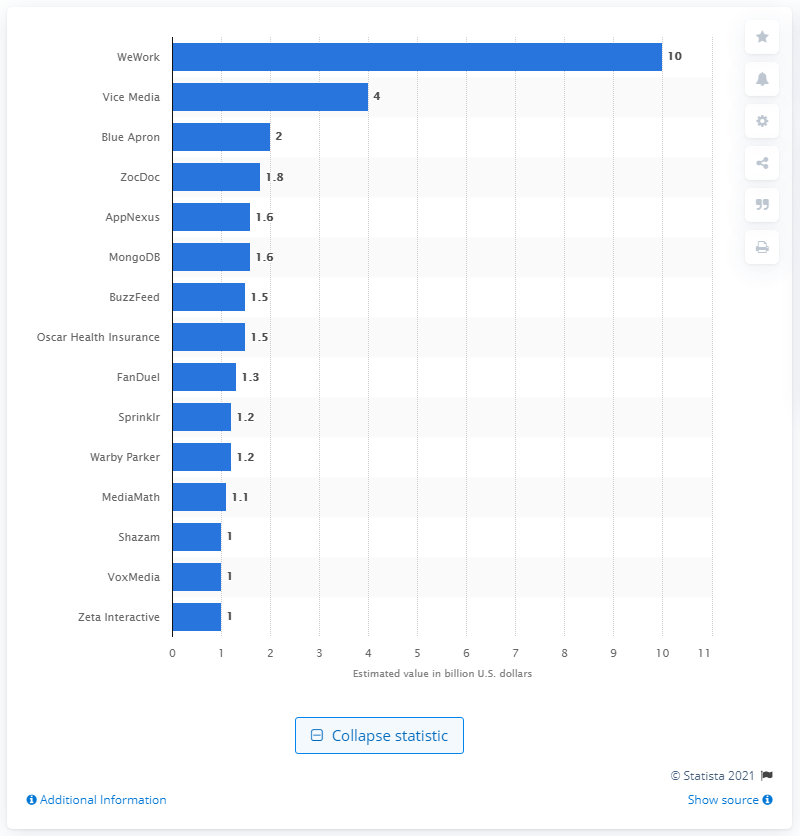Indicate a few pertinent items in this graphic. As of 2016, WeWork was valued at approximately $10 billion dollars. 